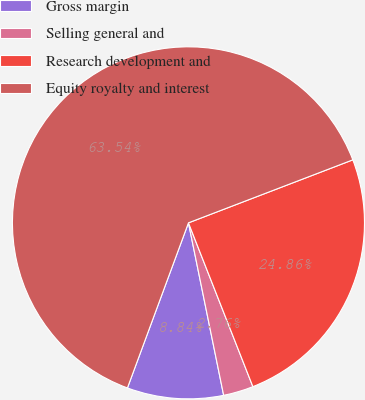Convert chart. <chart><loc_0><loc_0><loc_500><loc_500><pie_chart><fcel>Gross margin<fcel>Selling general and<fcel>Research development and<fcel>Equity royalty and interest<nl><fcel>8.84%<fcel>2.76%<fcel>24.86%<fcel>63.54%<nl></chart> 